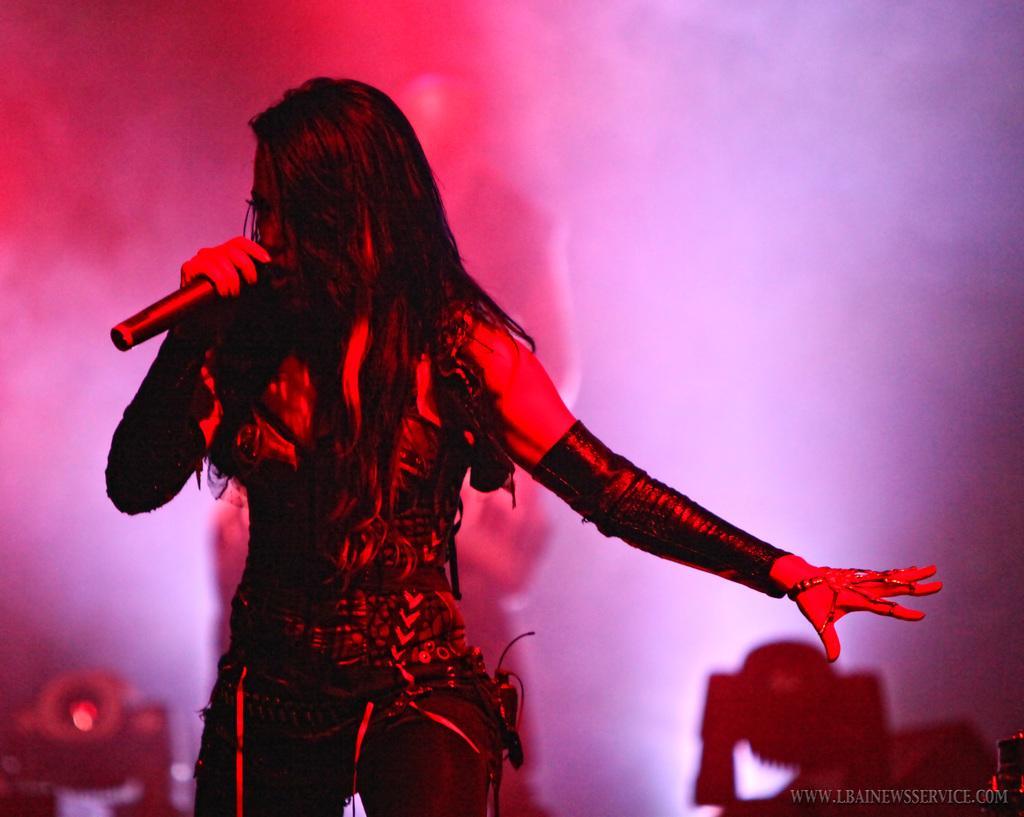Describe this image in one or two sentences. In this image there is a lady standing and holding a mic. In the background there are lights and we can see a person. 